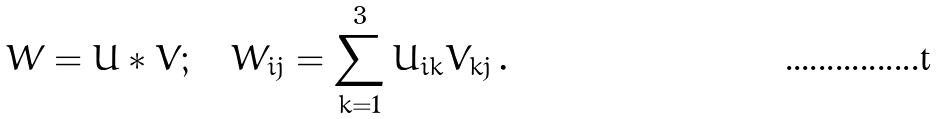Convert formula to latex. <formula><loc_0><loc_0><loc_500><loc_500>W = U * V ; \quad W _ { i j } = \sum _ { k = 1 } ^ { 3 } U _ { i k } V _ { k j } \, .</formula> 